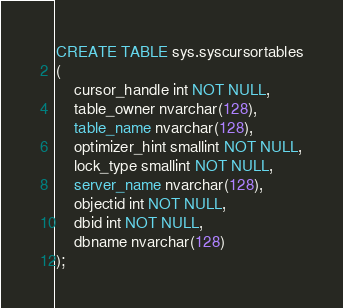<code> <loc_0><loc_0><loc_500><loc_500><_SQL_>CREATE TABLE sys.syscursortables
(
    cursor_handle int NOT NULL,
    table_owner nvarchar(128),
    table_name nvarchar(128),
    optimizer_hint smallint NOT NULL,
    lock_type smallint NOT NULL,
    server_name nvarchar(128),
    objectid int NOT NULL,
    dbid int NOT NULL,
    dbname nvarchar(128)
);</code> 